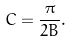Convert formula to latex. <formula><loc_0><loc_0><loc_500><loc_500>C = \frac { \pi } { 2 B } .</formula> 